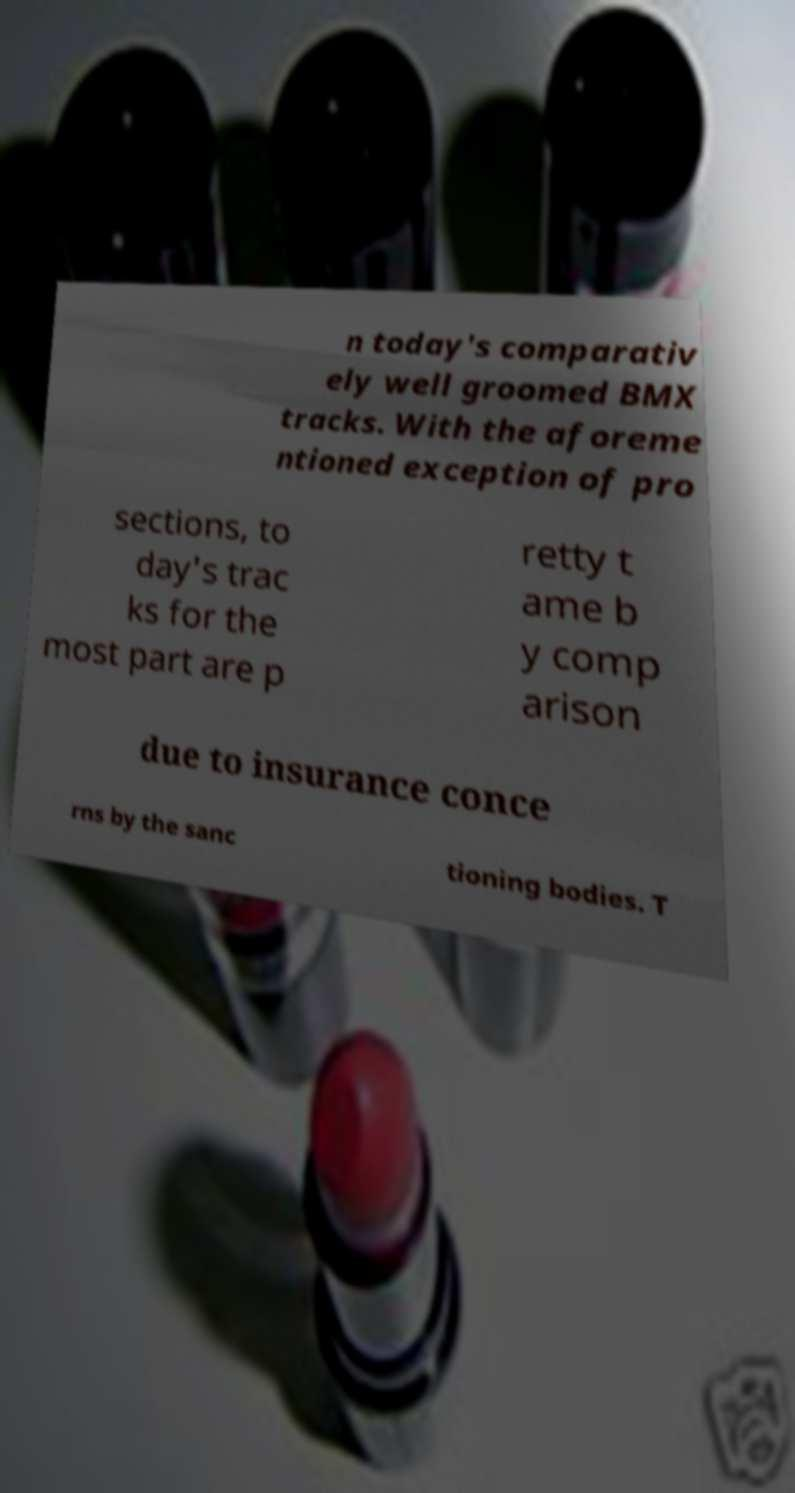Can you accurately transcribe the text from the provided image for me? n today's comparativ ely well groomed BMX tracks. With the aforeme ntioned exception of pro sections, to day's trac ks for the most part are p retty t ame b y comp arison due to insurance conce rns by the sanc tioning bodies. T 